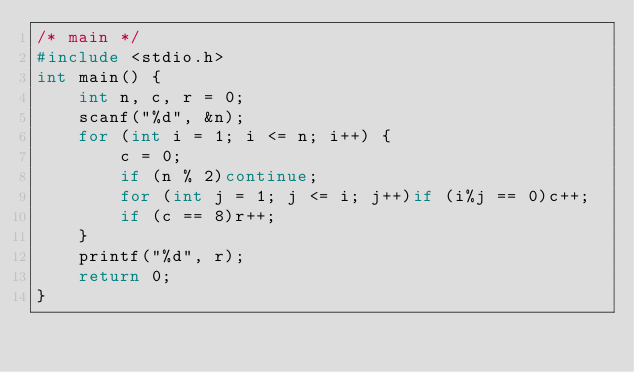Convert code to text. <code><loc_0><loc_0><loc_500><loc_500><_C_>/* main */
#include <stdio.h>
int main() {
	int n, c, r = 0;
	scanf("%d", &n);
	for (int i = 1; i <= n; i++) {
		c = 0;
		if (n % 2)continue;
		for (int j = 1; j <= i; j++)if (i%j == 0)c++;
		if (c == 8)r++;
	}
	printf("%d", r);
	return 0;
}</code> 